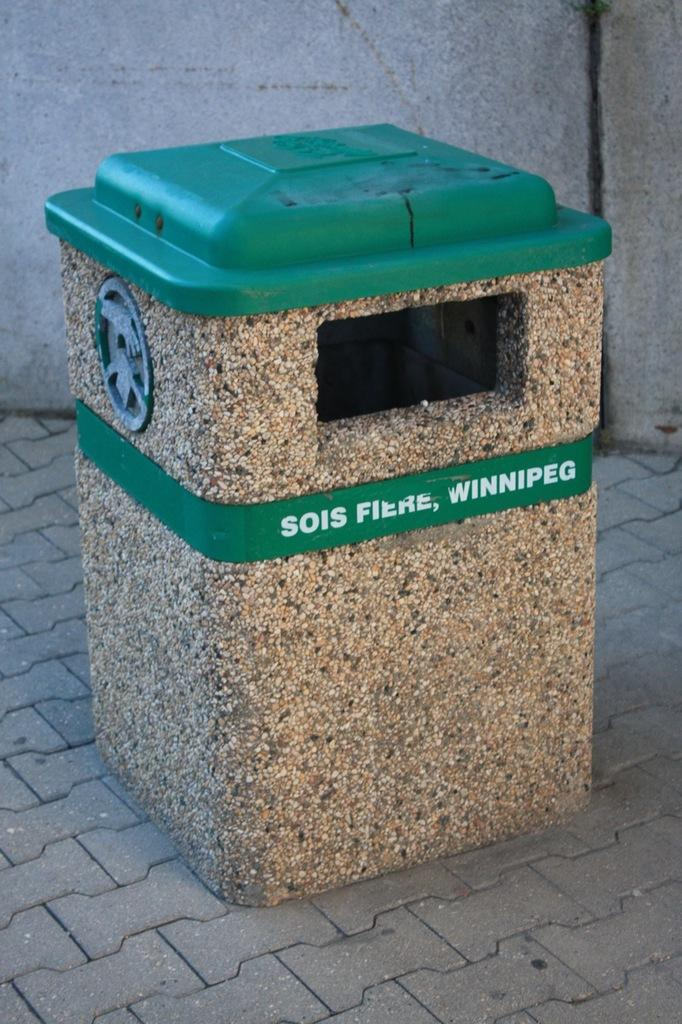<image>
Render a clear and concise summary of the photo. The garbage can here is in the city of Winnipeg 